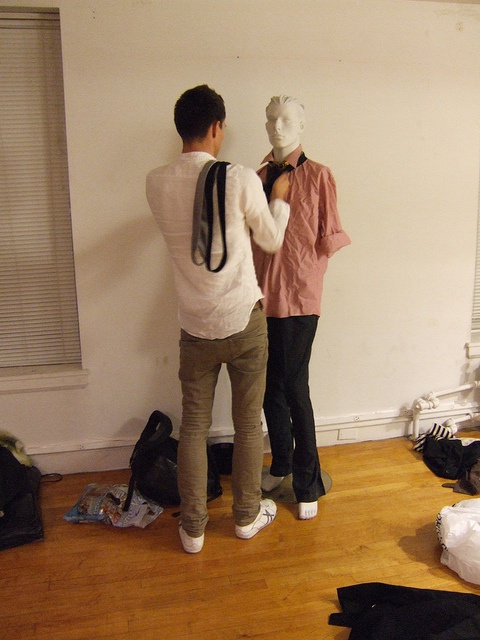Describe the objects in this image and their specific colors. I can see people in gray, maroon, and black tones, people in gray, black, brown, tan, and salmon tones, backpack in gray, black, and maroon tones, tie in gray, maroon, and black tones, and tie in gray, black, and maroon tones in this image. 